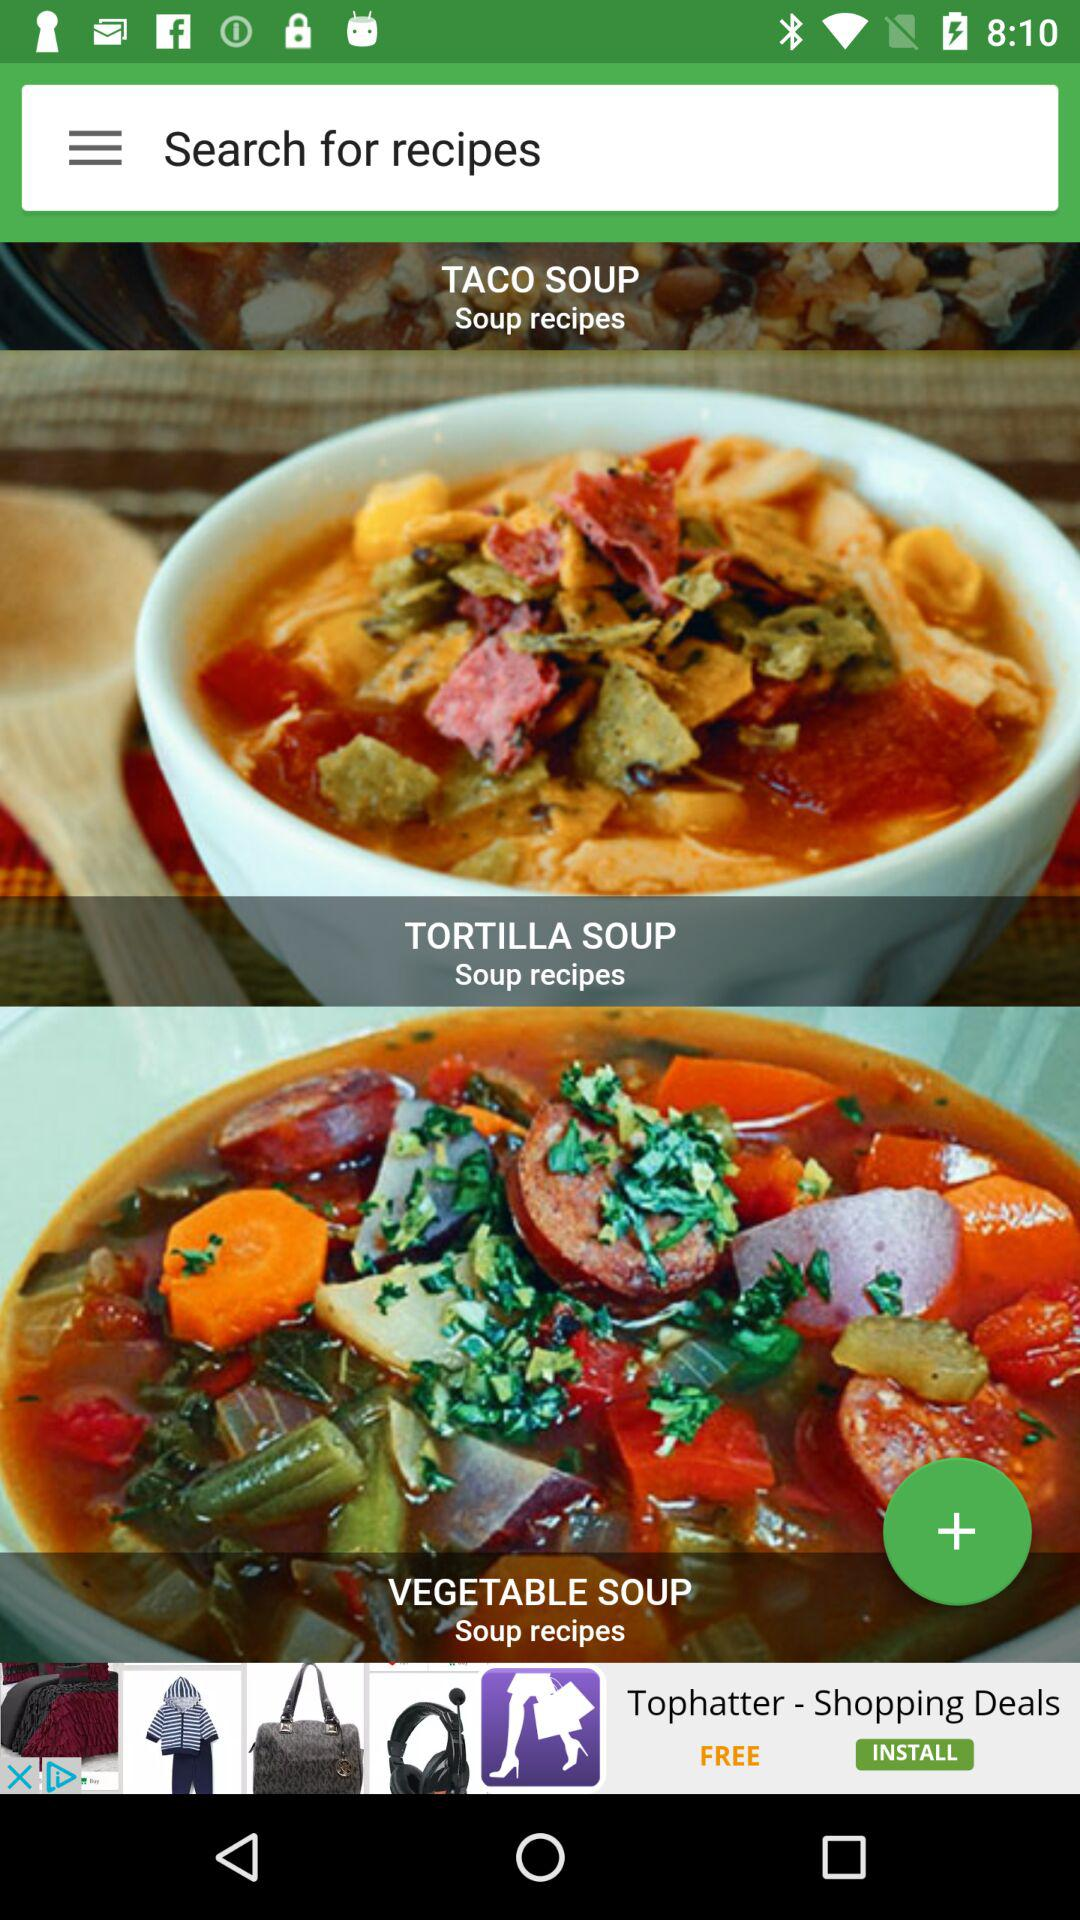How many soup recipes are there?
Answer the question using a single word or phrase. 3 